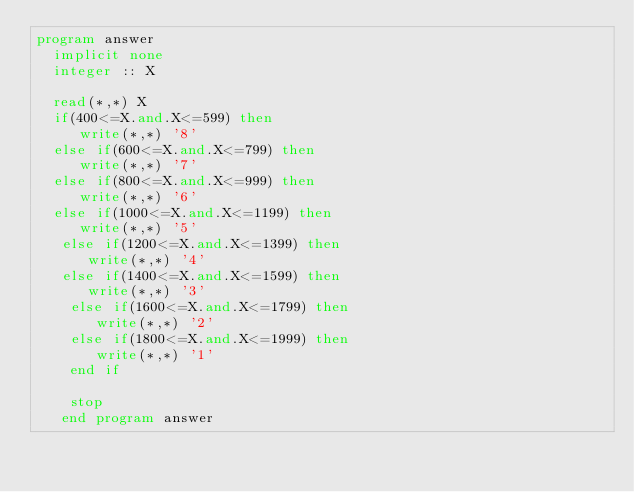<code> <loc_0><loc_0><loc_500><loc_500><_FORTRAN_>program answer
  implicit none
  integer :: X

  read(*,*) X
  if(400<=X.and.X<=599) then
     write(*,*) '8'
  else if(600<=X.and.X<=799) then
     write(*,*) '7'
  else if(800<=X.and.X<=999) then
     write(*,*) '6'
  else if(1000<=X.and.X<=1199) then
     write(*,*) '5'
   else if(1200<=X.and.X<=1399) then
      write(*,*) '4'
   else if(1400<=X.and.X<=1599) then
      write(*,*) '3'
    else if(1600<=X.and.X<=1799) then
       write(*,*) '2'
    else if(1800<=X.and.X<=1999) then
       write(*,*) '1'
    end if

    stop
   end program answer</code> 